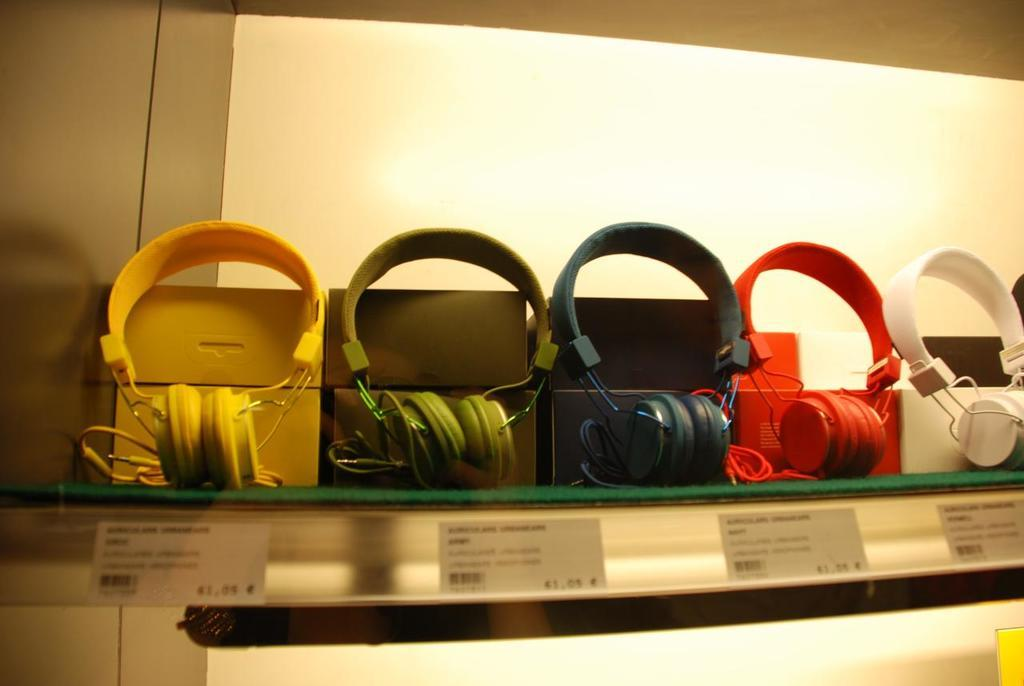What type of product is featured in the image? The image features headphones. How are the headphones differentiated from one another? The headphones come in different colors. Where are the headphones located in the image? The headphones are on display. How can the price of the headphones be determined? Price tags are associated with the headphones. What type of sign can be seen on top of the headphones in the image? There is no sign visible on top of the headphones in the image. 